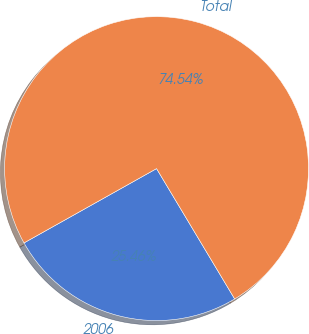<chart> <loc_0><loc_0><loc_500><loc_500><pie_chart><fcel>2006<fcel>Total<nl><fcel>25.46%<fcel>74.54%<nl></chart> 